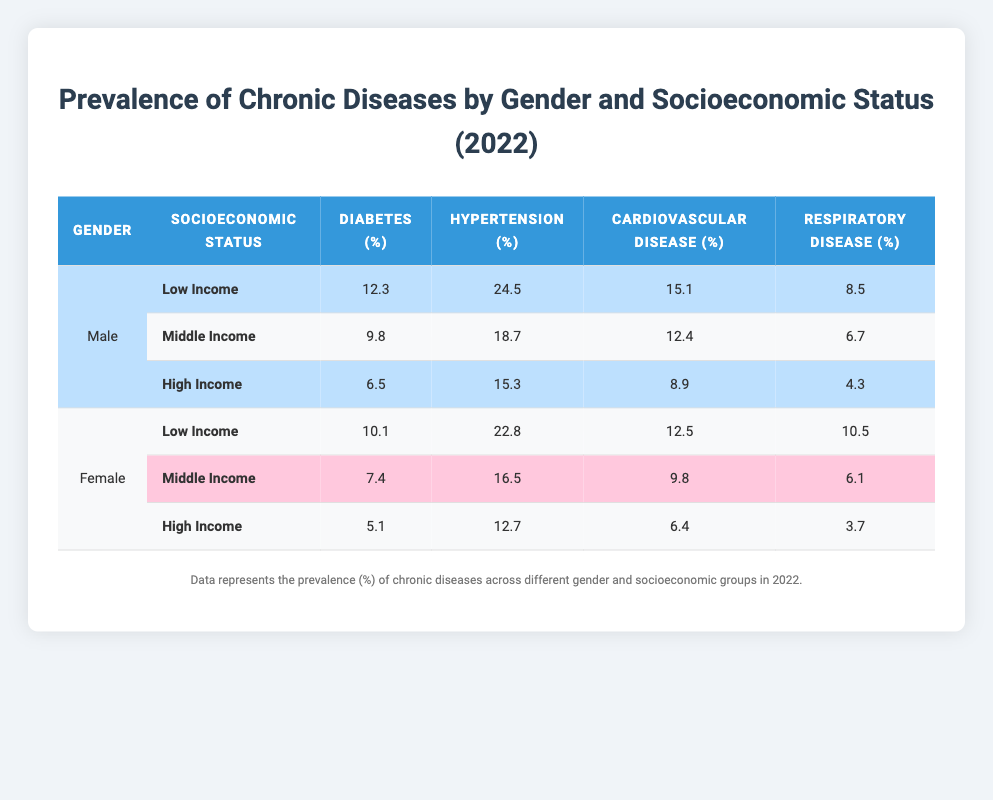What is the prevalence of hypertension among low-income males? Looking at the table, for low-income males, the prevalence of hypertension is listed as 24.5%.
Answer: 24.5% Which gender has a higher prevalence of diabetes among those with high income? For high-income individuals, male diabetes prevalence is 6.5% and female prevalence is 5.1%. Thus, males have a higher prevalence.
Answer: Male What is the average prevalence of respiratory disease for low-income individuals, regardless of gender? For low-income individuals, the respiratory disease prevalence is 8.5% (males) and 10.5% (females). To find the average: (8.5 + 10.5) / 2 = 9.5%.
Answer: 9.5% True or False: The prevalence of cardiovascular disease is higher among low-income females than among middle-income males. For low-income females, the cardiovascular disease prevalence is 12.5%, whereas for middle-income males, it is 12.4%. Since 12.5% > 12.4%, the statement is true.
Answer: True What is the difference in diabetes prevalence between low-income males and low-income females? The prevalence of diabetes for low-income males is 12.3% and for low-income females is 10.1%. The difference is 12.3% - 10.1% = 2.2%.
Answer: 2.2% 